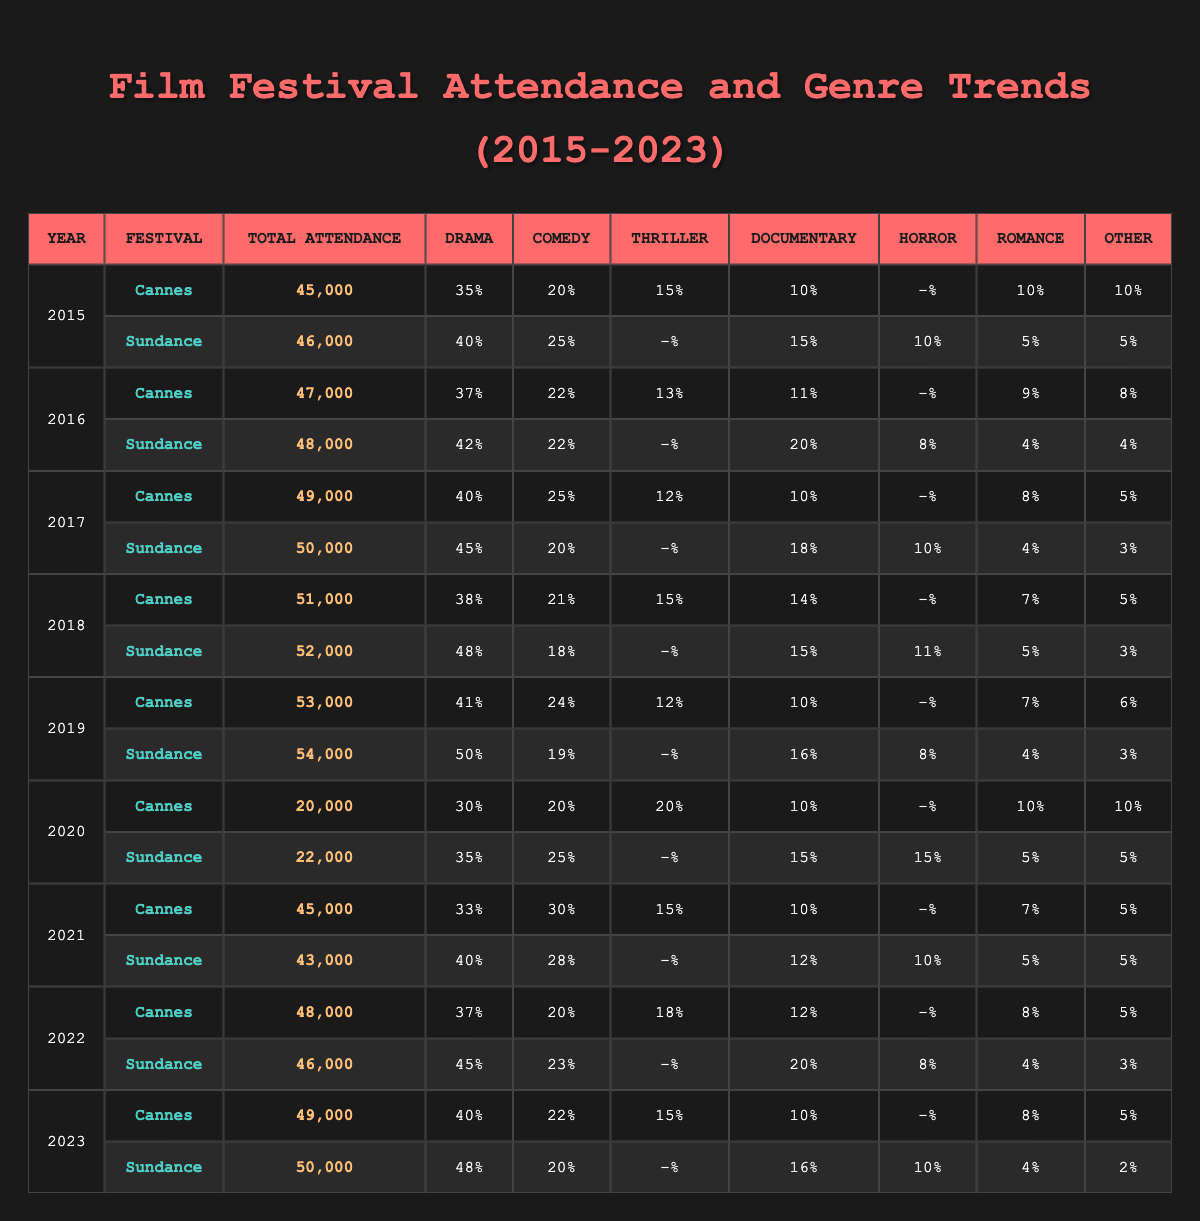What was the total attendance at the Cannes Film Festival in 2017? The total attendance for Cannes in 2017 can be found in the "Total Attendance" column corresponding to the year 2017. The value listed is 49,000.
Answer: 49,000 How much did the attendance at Sundance change from 2019 to 2021? The total attendance at Sundance in 2019 was 54,000 and in 2021 it was 43,000. To find the change, subtract 43,000 from 54,000: 54,000 - 43,000 = 11,000.
Answer: 11,000 Did the percentage of documentary films at Cannes increase or decrease from 2015 to 2022? In 2015, the percentage of documentary films at Cannes was 10%. In 2022, it was 12%. Since 12% is greater than 10%, the percentage increased over the years.
Answer: Yes What was the average percentage of drama films at Sundance from 2015 to 2023? The percentages for drama films at Sundance each year are as follows: 40, 42, 45, 48, 50, 35, 40, 45. Adding these values gives 345, and there are 8 data points, so the average is 345 / 8 = 43.125.
Answer: 43.125 Which genre had the highest percentage at Cannes in 2020? To find this, we look at the genre breakdown for Cannes in 2020: Drama (30%), Comedy (20%), Thriller (20%), Documentary (10%), Romance (10%), Other (10%). The highest percentage is for Drama at 30%.
Answer: Drama What was the change in the percentage of romance films at Sundance from 2015 to 2023? The percentage of romance films at Sundance in 2015 was 5%. In 2023, it was 4%. The change is calculated as 4% - 5% = -1%, indicating a decrease.
Answer: Decrease Is it true that the attendance at Cannes was lower in 2020 compared to 2019? The total attendance at Cannes in 2019 was 53,000 and in 2020 it was 20,000. Since 20,000 is lower than 53,000, the statement is true.
Answer: Yes What was the total attendance for both festivals combined in 2021? The total attendance for Cannes in 2021 was 45,000 and for Sundance, it was 43,000. Adding these two figures together gives 45,000 + 43,000 = 88,000.
Answer: 88,000 In which year did Sundance have the highest attendance? By examining the total attendance values for Sundance over the years, we see that the highest attendance was 54,000, occurring in 2019.
Answer: 2019 